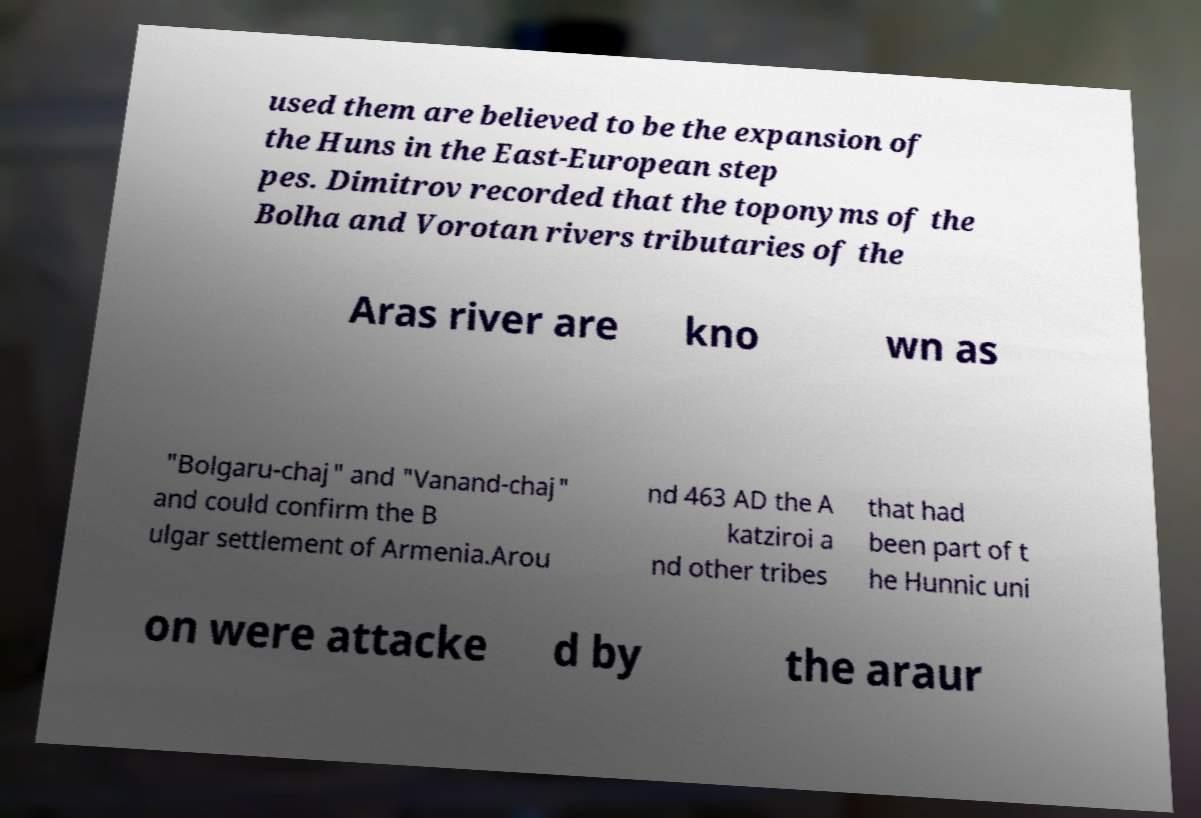There's text embedded in this image that I need extracted. Can you transcribe it verbatim? used them are believed to be the expansion of the Huns in the East-European step pes. Dimitrov recorded that the toponyms of the Bolha and Vorotan rivers tributaries of the Aras river are kno wn as "Bolgaru-chaj" and "Vanand-chaj" and could confirm the B ulgar settlement of Armenia.Arou nd 463 AD the A katziroi a nd other tribes that had been part of t he Hunnic uni on were attacke d by the araur 